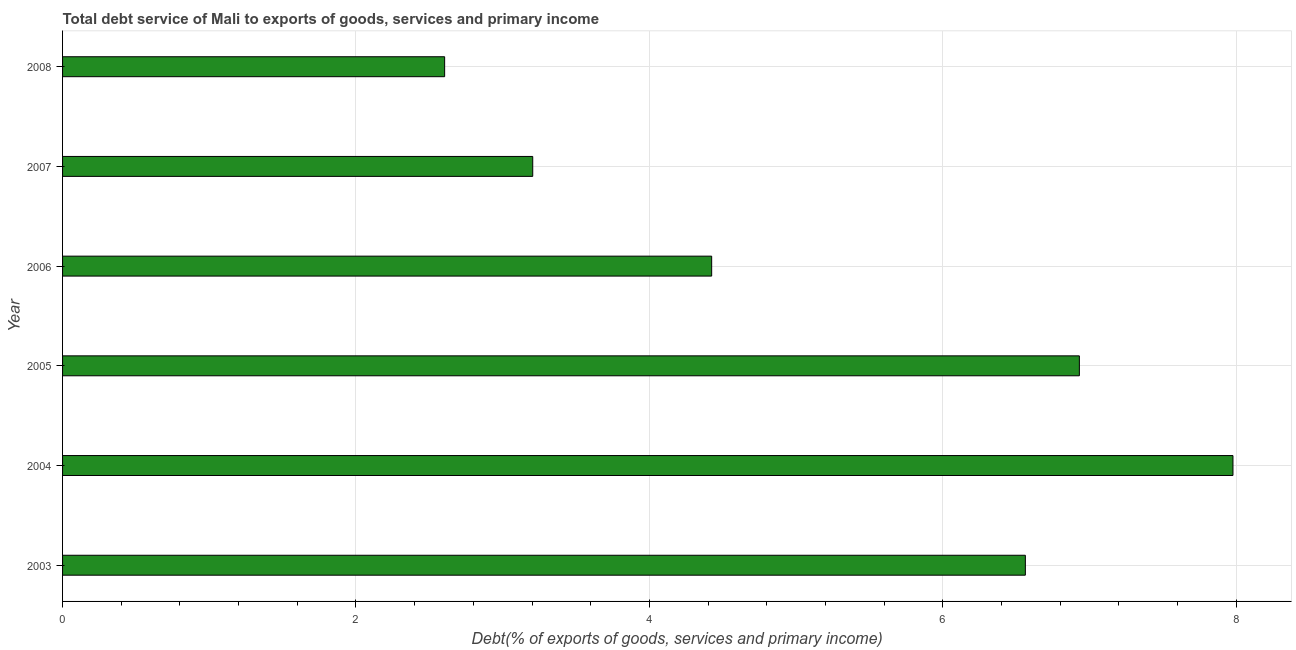What is the title of the graph?
Provide a succinct answer. Total debt service of Mali to exports of goods, services and primary income. What is the label or title of the X-axis?
Your answer should be compact. Debt(% of exports of goods, services and primary income). What is the total debt service in 2008?
Provide a succinct answer. 2.6. Across all years, what is the maximum total debt service?
Ensure brevity in your answer.  7.98. Across all years, what is the minimum total debt service?
Give a very brief answer. 2.6. What is the sum of the total debt service?
Your answer should be very brief. 31.71. What is the difference between the total debt service in 2004 and 2006?
Provide a succinct answer. 3.55. What is the average total debt service per year?
Keep it short and to the point. 5.28. What is the median total debt service?
Offer a very short reply. 5.49. In how many years, is the total debt service greater than 7.6 %?
Offer a very short reply. 1. What is the ratio of the total debt service in 2006 to that in 2008?
Your answer should be very brief. 1.7. Is the total debt service in 2004 less than that in 2005?
Your response must be concise. No. What is the difference between the highest and the second highest total debt service?
Your answer should be very brief. 1.05. Is the sum of the total debt service in 2006 and 2007 greater than the maximum total debt service across all years?
Offer a terse response. No. What is the difference between the highest and the lowest total debt service?
Make the answer very short. 5.37. How many bars are there?
Provide a succinct answer. 6. Are all the bars in the graph horizontal?
Your response must be concise. Yes. How many years are there in the graph?
Your answer should be compact. 6. What is the difference between two consecutive major ticks on the X-axis?
Your response must be concise. 2. Are the values on the major ticks of X-axis written in scientific E-notation?
Your answer should be compact. No. What is the Debt(% of exports of goods, services and primary income) in 2003?
Provide a short and direct response. 6.56. What is the Debt(% of exports of goods, services and primary income) of 2004?
Offer a terse response. 7.98. What is the Debt(% of exports of goods, services and primary income) of 2005?
Make the answer very short. 6.93. What is the Debt(% of exports of goods, services and primary income) of 2006?
Keep it short and to the point. 4.42. What is the Debt(% of exports of goods, services and primary income) in 2007?
Your response must be concise. 3.2. What is the Debt(% of exports of goods, services and primary income) of 2008?
Your response must be concise. 2.6. What is the difference between the Debt(% of exports of goods, services and primary income) in 2003 and 2004?
Provide a short and direct response. -1.42. What is the difference between the Debt(% of exports of goods, services and primary income) in 2003 and 2005?
Your answer should be compact. -0.37. What is the difference between the Debt(% of exports of goods, services and primary income) in 2003 and 2006?
Your answer should be compact. 2.14. What is the difference between the Debt(% of exports of goods, services and primary income) in 2003 and 2007?
Offer a terse response. 3.36. What is the difference between the Debt(% of exports of goods, services and primary income) in 2003 and 2008?
Give a very brief answer. 3.96. What is the difference between the Debt(% of exports of goods, services and primary income) in 2004 and 2005?
Keep it short and to the point. 1.05. What is the difference between the Debt(% of exports of goods, services and primary income) in 2004 and 2006?
Ensure brevity in your answer.  3.55. What is the difference between the Debt(% of exports of goods, services and primary income) in 2004 and 2007?
Keep it short and to the point. 4.77. What is the difference between the Debt(% of exports of goods, services and primary income) in 2004 and 2008?
Make the answer very short. 5.37. What is the difference between the Debt(% of exports of goods, services and primary income) in 2005 and 2006?
Give a very brief answer. 2.51. What is the difference between the Debt(% of exports of goods, services and primary income) in 2005 and 2007?
Ensure brevity in your answer.  3.73. What is the difference between the Debt(% of exports of goods, services and primary income) in 2005 and 2008?
Keep it short and to the point. 4.33. What is the difference between the Debt(% of exports of goods, services and primary income) in 2006 and 2007?
Provide a succinct answer. 1.22. What is the difference between the Debt(% of exports of goods, services and primary income) in 2006 and 2008?
Your answer should be compact. 1.82. What is the difference between the Debt(% of exports of goods, services and primary income) in 2007 and 2008?
Keep it short and to the point. 0.6. What is the ratio of the Debt(% of exports of goods, services and primary income) in 2003 to that in 2004?
Provide a short and direct response. 0.82. What is the ratio of the Debt(% of exports of goods, services and primary income) in 2003 to that in 2005?
Provide a succinct answer. 0.95. What is the ratio of the Debt(% of exports of goods, services and primary income) in 2003 to that in 2006?
Offer a very short reply. 1.48. What is the ratio of the Debt(% of exports of goods, services and primary income) in 2003 to that in 2007?
Keep it short and to the point. 2.05. What is the ratio of the Debt(% of exports of goods, services and primary income) in 2003 to that in 2008?
Your answer should be very brief. 2.52. What is the ratio of the Debt(% of exports of goods, services and primary income) in 2004 to that in 2005?
Provide a short and direct response. 1.15. What is the ratio of the Debt(% of exports of goods, services and primary income) in 2004 to that in 2006?
Offer a very short reply. 1.8. What is the ratio of the Debt(% of exports of goods, services and primary income) in 2004 to that in 2007?
Ensure brevity in your answer.  2.49. What is the ratio of the Debt(% of exports of goods, services and primary income) in 2004 to that in 2008?
Make the answer very short. 3.06. What is the ratio of the Debt(% of exports of goods, services and primary income) in 2005 to that in 2006?
Offer a very short reply. 1.57. What is the ratio of the Debt(% of exports of goods, services and primary income) in 2005 to that in 2007?
Provide a succinct answer. 2.16. What is the ratio of the Debt(% of exports of goods, services and primary income) in 2005 to that in 2008?
Give a very brief answer. 2.66. What is the ratio of the Debt(% of exports of goods, services and primary income) in 2006 to that in 2007?
Provide a short and direct response. 1.38. What is the ratio of the Debt(% of exports of goods, services and primary income) in 2006 to that in 2008?
Your response must be concise. 1.7. What is the ratio of the Debt(% of exports of goods, services and primary income) in 2007 to that in 2008?
Your answer should be very brief. 1.23. 